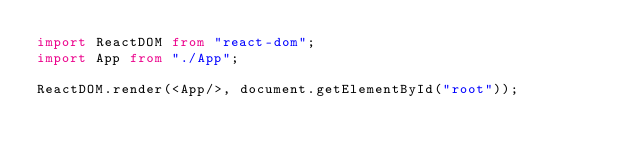Convert code to text. <code><loc_0><loc_0><loc_500><loc_500><_TypeScript_>import ReactDOM from "react-dom";
import App from "./App";

ReactDOM.render(<App/>, document.getElementById("root"));


</code> 